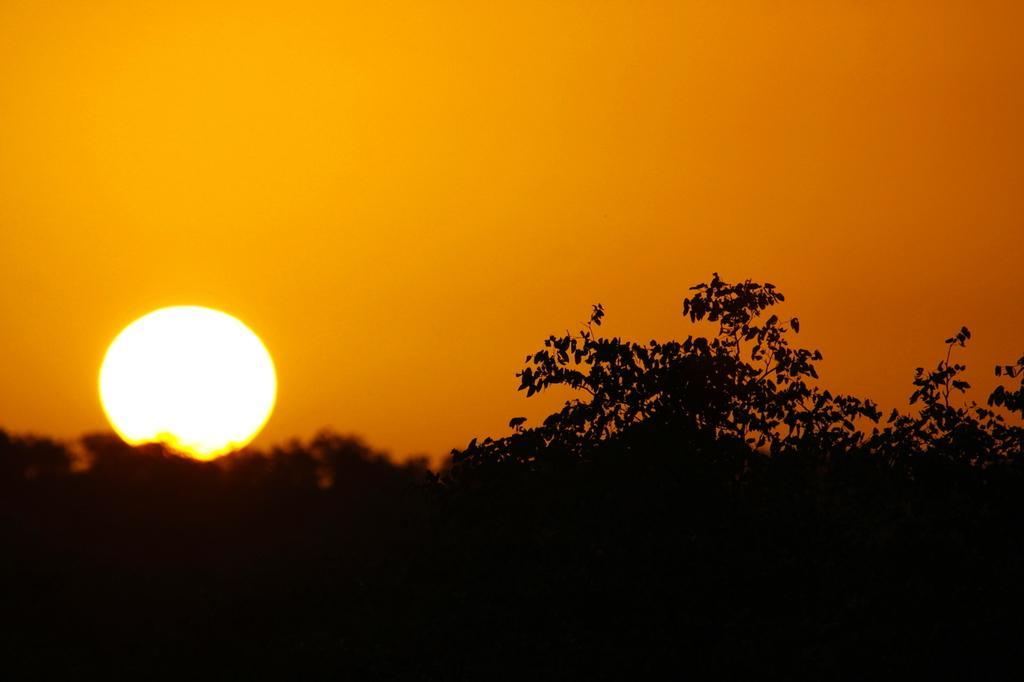Can you describe this image briefly? In this image there are trees, sun in the sky. 